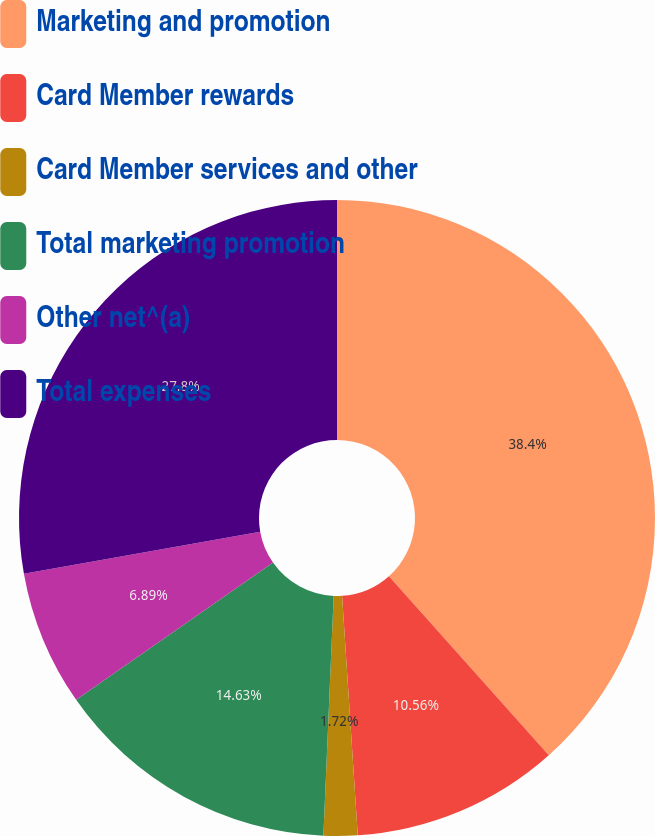Convert chart to OTSL. <chart><loc_0><loc_0><loc_500><loc_500><pie_chart><fcel>Marketing and promotion<fcel>Card Member rewards<fcel>Card Member services and other<fcel>Total marketing promotion<fcel>Other net^(a)<fcel>Total expenses<nl><fcel>38.4%<fcel>10.56%<fcel>1.72%<fcel>14.63%<fcel>6.89%<fcel>27.8%<nl></chart> 